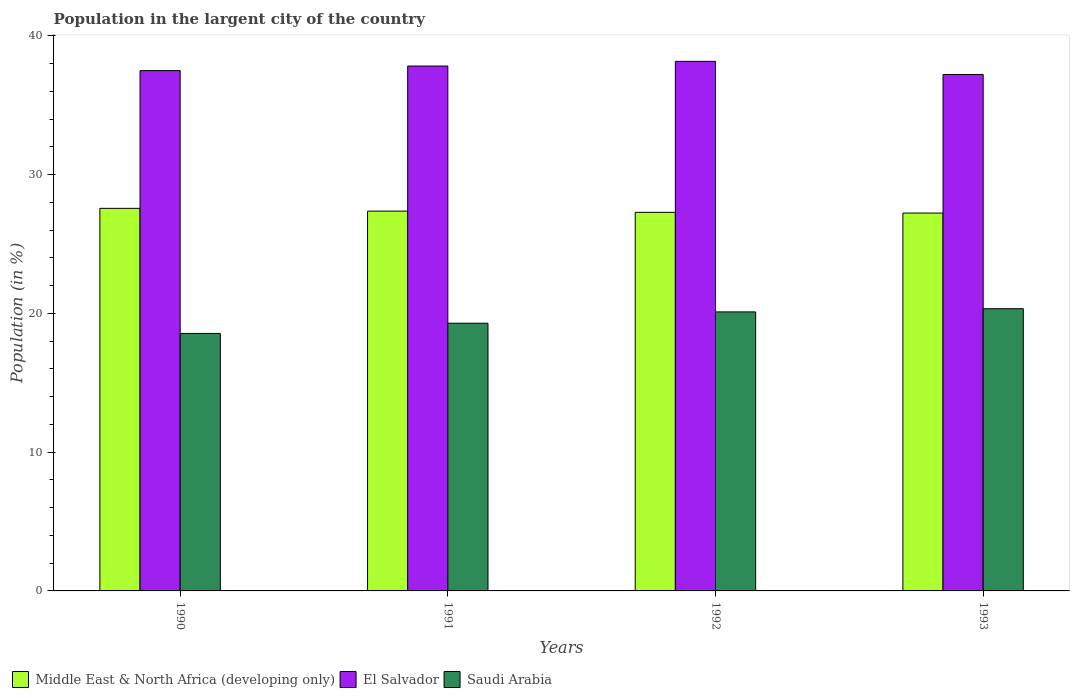How many groups of bars are there?
Offer a terse response. 4. Are the number of bars per tick equal to the number of legend labels?
Keep it short and to the point. Yes. Are the number of bars on each tick of the X-axis equal?
Give a very brief answer. Yes. How many bars are there on the 3rd tick from the right?
Keep it short and to the point. 3. In how many cases, is the number of bars for a given year not equal to the number of legend labels?
Ensure brevity in your answer.  0. What is the percentage of population in the largent city in Saudi Arabia in 1993?
Your answer should be very brief. 20.34. Across all years, what is the maximum percentage of population in the largent city in Saudi Arabia?
Offer a very short reply. 20.34. Across all years, what is the minimum percentage of population in the largent city in Middle East & North Africa (developing only)?
Offer a terse response. 27.23. In which year was the percentage of population in the largent city in Middle East & North Africa (developing only) maximum?
Offer a very short reply. 1990. What is the total percentage of population in the largent city in El Salvador in the graph?
Give a very brief answer. 150.71. What is the difference between the percentage of population in the largent city in Middle East & North Africa (developing only) in 1990 and that in 1991?
Your response must be concise. 0.2. What is the difference between the percentage of population in the largent city in Middle East & North Africa (developing only) in 1992 and the percentage of population in the largent city in Saudi Arabia in 1991?
Ensure brevity in your answer.  7.99. What is the average percentage of population in the largent city in El Salvador per year?
Your response must be concise. 37.68. In the year 1992, what is the difference between the percentage of population in the largent city in Saudi Arabia and percentage of population in the largent city in Middle East & North Africa (developing only)?
Give a very brief answer. -7.18. In how many years, is the percentage of population in the largent city in El Salvador greater than 18 %?
Give a very brief answer. 4. What is the ratio of the percentage of population in the largent city in El Salvador in 1992 to that in 1993?
Your answer should be compact. 1.03. Is the percentage of population in the largent city in Middle East & North Africa (developing only) in 1990 less than that in 1991?
Offer a very short reply. No. Is the difference between the percentage of population in the largent city in Saudi Arabia in 1991 and 1993 greater than the difference between the percentage of population in the largent city in Middle East & North Africa (developing only) in 1991 and 1993?
Your response must be concise. No. What is the difference between the highest and the second highest percentage of population in the largent city in Saudi Arabia?
Offer a terse response. 0.23. What is the difference between the highest and the lowest percentage of population in the largent city in Saudi Arabia?
Make the answer very short. 1.78. Is the sum of the percentage of population in the largent city in Middle East & North Africa (developing only) in 1990 and 1992 greater than the maximum percentage of population in the largent city in El Salvador across all years?
Offer a very short reply. Yes. What does the 3rd bar from the left in 1991 represents?
Offer a terse response. Saudi Arabia. What does the 3rd bar from the right in 1991 represents?
Ensure brevity in your answer.  Middle East & North Africa (developing only). Is it the case that in every year, the sum of the percentage of population in the largent city in Saudi Arabia and percentage of population in the largent city in El Salvador is greater than the percentage of population in the largent city in Middle East & North Africa (developing only)?
Offer a very short reply. Yes. How many bars are there?
Offer a terse response. 12. How many years are there in the graph?
Give a very brief answer. 4. What is the difference between two consecutive major ticks on the Y-axis?
Make the answer very short. 10. Are the values on the major ticks of Y-axis written in scientific E-notation?
Provide a succinct answer. No. Does the graph contain grids?
Provide a short and direct response. No. Where does the legend appear in the graph?
Keep it short and to the point. Bottom left. What is the title of the graph?
Offer a terse response. Population in the largent city of the country. What is the Population (in %) of Middle East & North Africa (developing only) in 1990?
Provide a short and direct response. 27.57. What is the Population (in %) of El Salvador in 1990?
Provide a short and direct response. 37.5. What is the Population (in %) in Saudi Arabia in 1990?
Ensure brevity in your answer.  18.56. What is the Population (in %) in Middle East & North Africa (developing only) in 1991?
Make the answer very short. 27.37. What is the Population (in %) of El Salvador in 1991?
Your answer should be very brief. 37.83. What is the Population (in %) in Saudi Arabia in 1991?
Your response must be concise. 19.29. What is the Population (in %) in Middle East & North Africa (developing only) in 1992?
Offer a terse response. 27.28. What is the Population (in %) of El Salvador in 1992?
Provide a succinct answer. 38.17. What is the Population (in %) in Saudi Arabia in 1992?
Provide a short and direct response. 20.11. What is the Population (in %) in Middle East & North Africa (developing only) in 1993?
Provide a succinct answer. 27.23. What is the Population (in %) of El Salvador in 1993?
Ensure brevity in your answer.  37.22. What is the Population (in %) in Saudi Arabia in 1993?
Your answer should be very brief. 20.34. Across all years, what is the maximum Population (in %) of Middle East & North Africa (developing only)?
Your answer should be compact. 27.57. Across all years, what is the maximum Population (in %) in El Salvador?
Offer a very short reply. 38.17. Across all years, what is the maximum Population (in %) of Saudi Arabia?
Offer a very short reply. 20.34. Across all years, what is the minimum Population (in %) of Middle East & North Africa (developing only)?
Provide a short and direct response. 27.23. Across all years, what is the minimum Population (in %) in El Salvador?
Offer a very short reply. 37.22. Across all years, what is the minimum Population (in %) in Saudi Arabia?
Keep it short and to the point. 18.56. What is the total Population (in %) in Middle East & North Africa (developing only) in the graph?
Keep it short and to the point. 109.46. What is the total Population (in %) of El Salvador in the graph?
Your response must be concise. 150.71. What is the total Population (in %) in Saudi Arabia in the graph?
Your answer should be compact. 78.3. What is the difference between the Population (in %) in Middle East & North Africa (developing only) in 1990 and that in 1991?
Give a very brief answer. 0.2. What is the difference between the Population (in %) of El Salvador in 1990 and that in 1991?
Your response must be concise. -0.33. What is the difference between the Population (in %) of Saudi Arabia in 1990 and that in 1991?
Make the answer very short. -0.74. What is the difference between the Population (in %) of Middle East & North Africa (developing only) in 1990 and that in 1992?
Offer a very short reply. 0.29. What is the difference between the Population (in %) in El Salvador in 1990 and that in 1992?
Keep it short and to the point. -0.67. What is the difference between the Population (in %) in Saudi Arabia in 1990 and that in 1992?
Offer a very short reply. -1.55. What is the difference between the Population (in %) in Middle East & North Africa (developing only) in 1990 and that in 1993?
Provide a short and direct response. 0.34. What is the difference between the Population (in %) in El Salvador in 1990 and that in 1993?
Your answer should be very brief. 0.28. What is the difference between the Population (in %) in Saudi Arabia in 1990 and that in 1993?
Ensure brevity in your answer.  -1.78. What is the difference between the Population (in %) in Middle East & North Africa (developing only) in 1991 and that in 1992?
Provide a short and direct response. 0.09. What is the difference between the Population (in %) of El Salvador in 1991 and that in 1992?
Your answer should be compact. -0.34. What is the difference between the Population (in %) of Saudi Arabia in 1991 and that in 1992?
Make the answer very short. -0.82. What is the difference between the Population (in %) of Middle East & North Africa (developing only) in 1991 and that in 1993?
Provide a succinct answer. 0.14. What is the difference between the Population (in %) of El Salvador in 1991 and that in 1993?
Your answer should be very brief. 0.61. What is the difference between the Population (in %) of Saudi Arabia in 1991 and that in 1993?
Your answer should be compact. -1.05. What is the difference between the Population (in %) of Middle East & North Africa (developing only) in 1992 and that in 1993?
Offer a very short reply. 0.05. What is the difference between the Population (in %) of El Salvador in 1992 and that in 1993?
Your response must be concise. 0.95. What is the difference between the Population (in %) of Saudi Arabia in 1992 and that in 1993?
Your answer should be compact. -0.23. What is the difference between the Population (in %) in Middle East & North Africa (developing only) in 1990 and the Population (in %) in El Salvador in 1991?
Provide a short and direct response. -10.26. What is the difference between the Population (in %) of Middle East & North Africa (developing only) in 1990 and the Population (in %) of Saudi Arabia in 1991?
Provide a short and direct response. 8.28. What is the difference between the Population (in %) in El Salvador in 1990 and the Population (in %) in Saudi Arabia in 1991?
Give a very brief answer. 18.21. What is the difference between the Population (in %) in Middle East & North Africa (developing only) in 1990 and the Population (in %) in El Salvador in 1992?
Your answer should be very brief. -10.59. What is the difference between the Population (in %) in Middle East & North Africa (developing only) in 1990 and the Population (in %) in Saudi Arabia in 1992?
Make the answer very short. 7.46. What is the difference between the Population (in %) of El Salvador in 1990 and the Population (in %) of Saudi Arabia in 1992?
Offer a very short reply. 17.39. What is the difference between the Population (in %) of Middle East & North Africa (developing only) in 1990 and the Population (in %) of El Salvador in 1993?
Make the answer very short. -9.65. What is the difference between the Population (in %) of Middle East & North Africa (developing only) in 1990 and the Population (in %) of Saudi Arabia in 1993?
Your response must be concise. 7.23. What is the difference between the Population (in %) in El Salvador in 1990 and the Population (in %) in Saudi Arabia in 1993?
Provide a short and direct response. 17.16. What is the difference between the Population (in %) of Middle East & North Africa (developing only) in 1991 and the Population (in %) of El Salvador in 1992?
Your response must be concise. -10.79. What is the difference between the Population (in %) in Middle East & North Africa (developing only) in 1991 and the Population (in %) in Saudi Arabia in 1992?
Your answer should be very brief. 7.26. What is the difference between the Population (in %) in El Salvador in 1991 and the Population (in %) in Saudi Arabia in 1992?
Provide a succinct answer. 17.72. What is the difference between the Population (in %) in Middle East & North Africa (developing only) in 1991 and the Population (in %) in El Salvador in 1993?
Offer a very short reply. -9.85. What is the difference between the Population (in %) of Middle East & North Africa (developing only) in 1991 and the Population (in %) of Saudi Arabia in 1993?
Your answer should be very brief. 7.04. What is the difference between the Population (in %) of El Salvador in 1991 and the Population (in %) of Saudi Arabia in 1993?
Offer a terse response. 17.49. What is the difference between the Population (in %) in Middle East & North Africa (developing only) in 1992 and the Population (in %) in El Salvador in 1993?
Offer a terse response. -9.94. What is the difference between the Population (in %) in Middle East & North Africa (developing only) in 1992 and the Population (in %) in Saudi Arabia in 1993?
Offer a terse response. 6.95. What is the difference between the Population (in %) of El Salvador in 1992 and the Population (in %) of Saudi Arabia in 1993?
Offer a terse response. 17.83. What is the average Population (in %) in Middle East & North Africa (developing only) per year?
Offer a very short reply. 27.37. What is the average Population (in %) in El Salvador per year?
Your answer should be very brief. 37.68. What is the average Population (in %) of Saudi Arabia per year?
Offer a terse response. 19.57. In the year 1990, what is the difference between the Population (in %) of Middle East & North Africa (developing only) and Population (in %) of El Salvador?
Make the answer very short. -9.93. In the year 1990, what is the difference between the Population (in %) in Middle East & North Africa (developing only) and Population (in %) in Saudi Arabia?
Ensure brevity in your answer.  9.01. In the year 1990, what is the difference between the Population (in %) in El Salvador and Population (in %) in Saudi Arabia?
Your response must be concise. 18.94. In the year 1991, what is the difference between the Population (in %) of Middle East & North Africa (developing only) and Population (in %) of El Salvador?
Ensure brevity in your answer.  -10.45. In the year 1991, what is the difference between the Population (in %) of Middle East & North Africa (developing only) and Population (in %) of Saudi Arabia?
Offer a very short reply. 8.08. In the year 1991, what is the difference between the Population (in %) in El Salvador and Population (in %) in Saudi Arabia?
Keep it short and to the point. 18.54. In the year 1992, what is the difference between the Population (in %) in Middle East & North Africa (developing only) and Population (in %) in El Salvador?
Give a very brief answer. -10.88. In the year 1992, what is the difference between the Population (in %) in Middle East & North Africa (developing only) and Population (in %) in Saudi Arabia?
Keep it short and to the point. 7.18. In the year 1992, what is the difference between the Population (in %) in El Salvador and Population (in %) in Saudi Arabia?
Ensure brevity in your answer.  18.06. In the year 1993, what is the difference between the Population (in %) of Middle East & North Africa (developing only) and Population (in %) of El Salvador?
Offer a terse response. -9.99. In the year 1993, what is the difference between the Population (in %) of Middle East & North Africa (developing only) and Population (in %) of Saudi Arabia?
Offer a very short reply. 6.89. In the year 1993, what is the difference between the Population (in %) in El Salvador and Population (in %) in Saudi Arabia?
Provide a succinct answer. 16.88. What is the ratio of the Population (in %) in Middle East & North Africa (developing only) in 1990 to that in 1991?
Your answer should be very brief. 1.01. What is the ratio of the Population (in %) of Saudi Arabia in 1990 to that in 1991?
Your response must be concise. 0.96. What is the ratio of the Population (in %) of Middle East & North Africa (developing only) in 1990 to that in 1992?
Keep it short and to the point. 1.01. What is the ratio of the Population (in %) in El Salvador in 1990 to that in 1992?
Provide a short and direct response. 0.98. What is the ratio of the Population (in %) in Saudi Arabia in 1990 to that in 1992?
Offer a terse response. 0.92. What is the ratio of the Population (in %) in Middle East & North Africa (developing only) in 1990 to that in 1993?
Your response must be concise. 1.01. What is the ratio of the Population (in %) in El Salvador in 1990 to that in 1993?
Give a very brief answer. 1.01. What is the ratio of the Population (in %) in Saudi Arabia in 1990 to that in 1993?
Provide a short and direct response. 0.91. What is the ratio of the Population (in %) of El Salvador in 1991 to that in 1992?
Your response must be concise. 0.99. What is the ratio of the Population (in %) in Saudi Arabia in 1991 to that in 1992?
Ensure brevity in your answer.  0.96. What is the ratio of the Population (in %) in Middle East & North Africa (developing only) in 1991 to that in 1993?
Offer a terse response. 1.01. What is the ratio of the Population (in %) in El Salvador in 1991 to that in 1993?
Make the answer very short. 1.02. What is the ratio of the Population (in %) in Saudi Arabia in 1991 to that in 1993?
Make the answer very short. 0.95. What is the ratio of the Population (in %) in El Salvador in 1992 to that in 1993?
Provide a short and direct response. 1.03. What is the ratio of the Population (in %) in Saudi Arabia in 1992 to that in 1993?
Give a very brief answer. 0.99. What is the difference between the highest and the second highest Population (in %) of Middle East & North Africa (developing only)?
Your response must be concise. 0.2. What is the difference between the highest and the second highest Population (in %) of El Salvador?
Your response must be concise. 0.34. What is the difference between the highest and the second highest Population (in %) of Saudi Arabia?
Your answer should be compact. 0.23. What is the difference between the highest and the lowest Population (in %) of Middle East & North Africa (developing only)?
Keep it short and to the point. 0.34. What is the difference between the highest and the lowest Population (in %) in El Salvador?
Provide a short and direct response. 0.95. What is the difference between the highest and the lowest Population (in %) of Saudi Arabia?
Give a very brief answer. 1.78. 